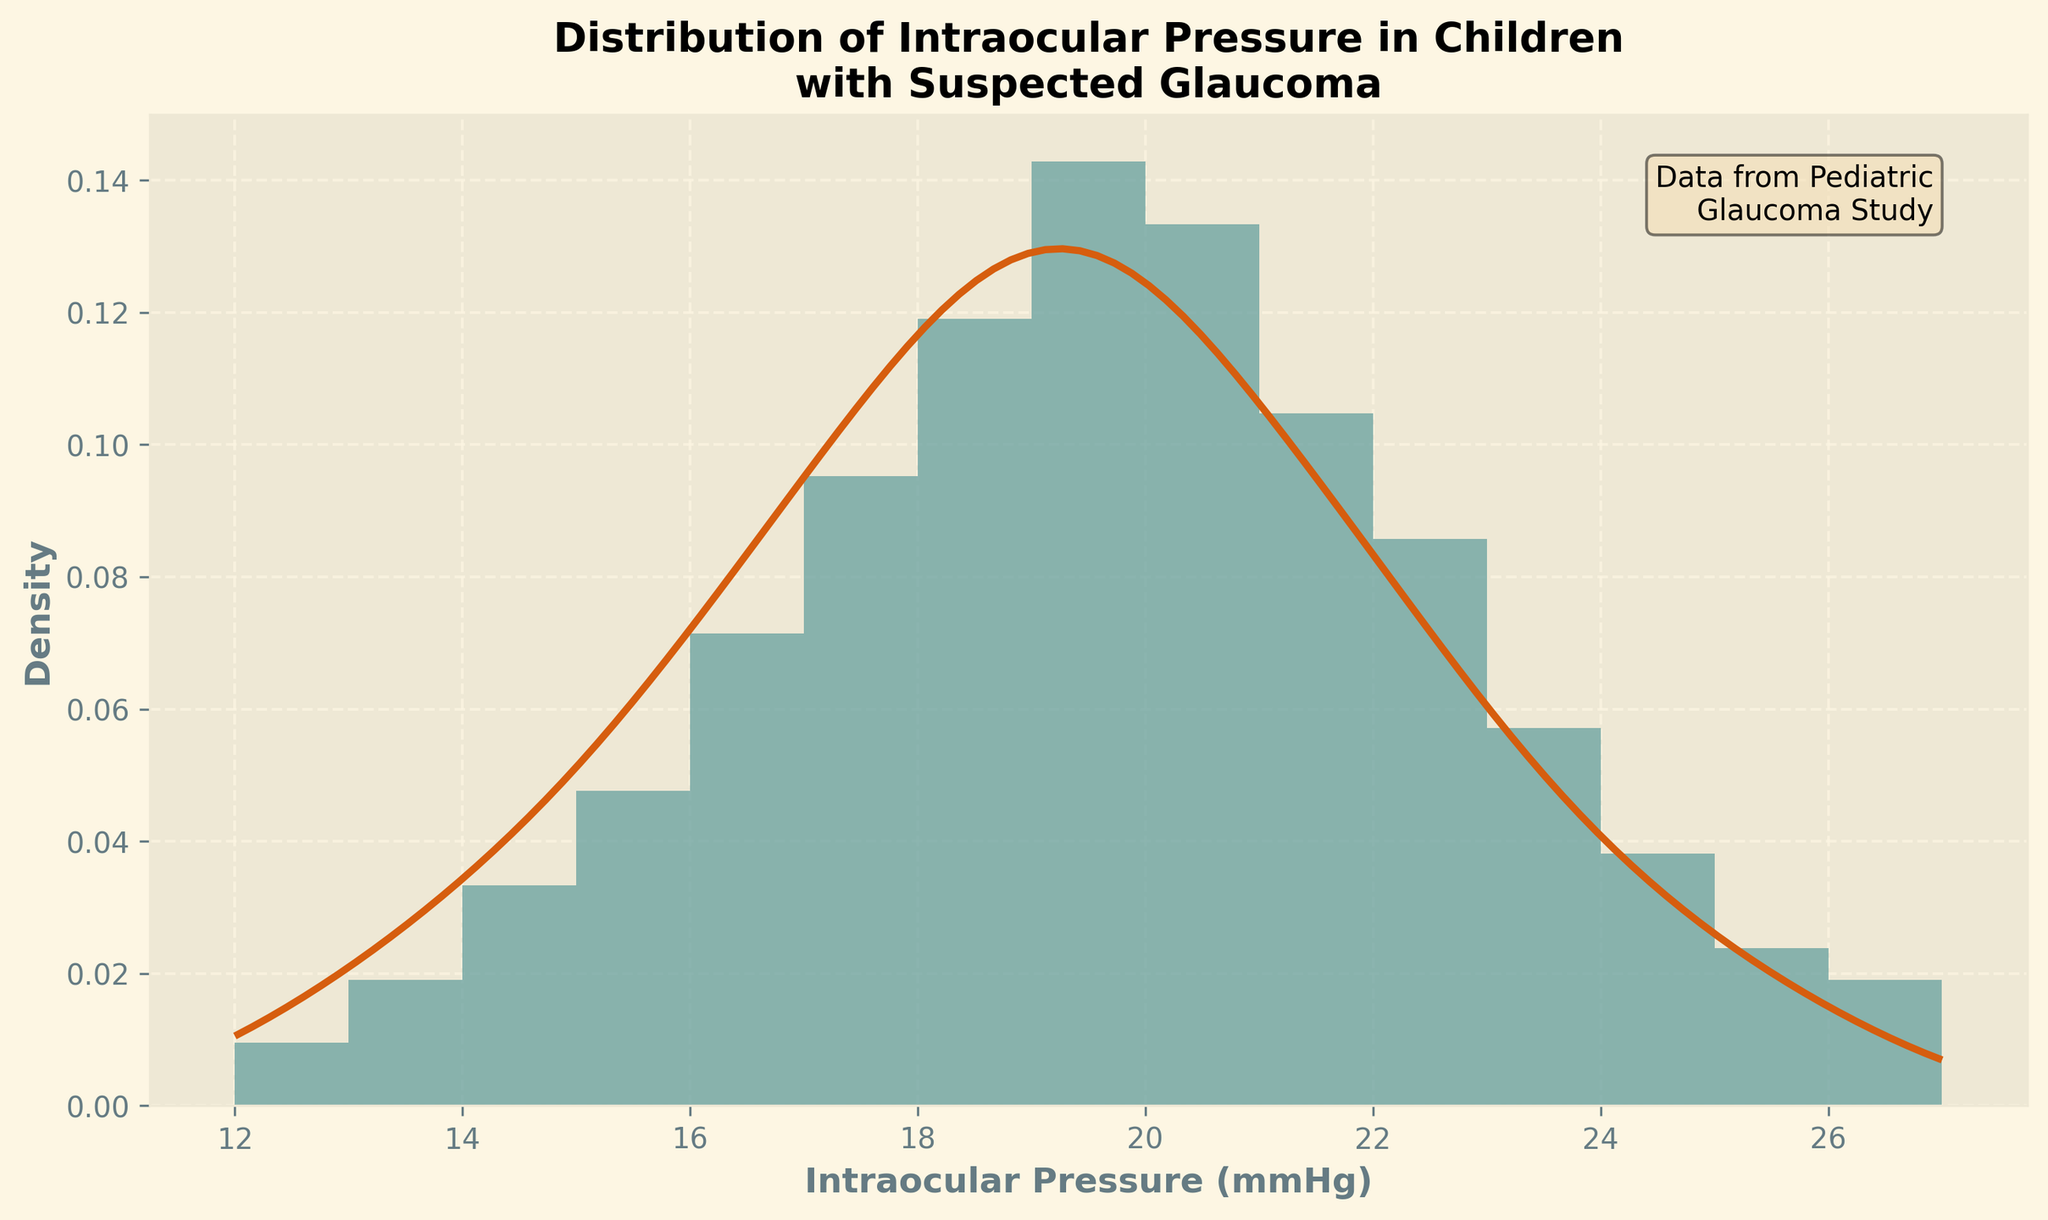What is the title of the plot? The title of the plot can be found at the top, which reads "Distribution of Intraocular Pressure in Children with Suspected Glaucoma."
Answer: Distribution of Intraocular Pressure in Children with Suspected Glaucoma What is the label of the x-axis? The x-axis label is below the x-axis, which states "Intraocular Pressure (mmHg)."
Answer: Intraocular Pressure (mmHg) Which intraocular pressure reading has the highest frequency according to the histogram? The tallest bar in the histogram corresponds to the intraocular pressure reading with the highest frequency. In this case, the reading of 19 mmHg is the tallest.
Answer: 19 mmHg Describe the overall shape of the KDE curve. The KDE curve starts low, rises to a peak around the middle, and then gradually decreases, showing a unimodal distribution with a peak around the 19 mmHg mark.
Answer: Unimodal with a peak around 19 mmHg How does the density at 16 mmHg compare to the density at 22 mmHg? Looking at the height of the KDE curve at both values, the density at 16 mmHg is higher than the density at 22 mmHg.
Answer: Higher at 16 mmHg What is the approximate range of intraocular pressures shown in the plot? The range can be determined by the spread of the x-axis, from the smallest to the largest values. The intraocular pressures range from about 12 mmHg to 27 mmHg.
Answer: 12 to 27 mmHg Around which intraocular pressure value does the KDE curve peak? The peak of the KDE curve represents the highest density of intraocular pressure, which appears to be around 19 mmHg.
Answer: 19 mmHg How many different intraocular pressure categories are there in the histogram? By counting the distinct bars in the histogram, there are 16 different intraocular pressure categories represented.
Answer: 16 categories What does the height of each bar in the histogram represent? The height of each bar represents the frequency or count density of the specific intraocular pressure readings.
Answer: Frequency of readings Does the histogram suggest that most children's intraocular pressures are on the lower, middle, or higher end of the range? By observing the distribution of bars, most of the pressures are concentrated towards the middle of the range.
Answer: Middle of the range 